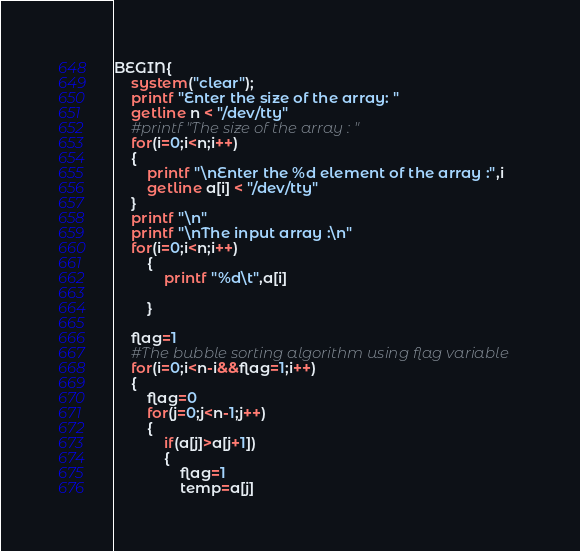<code> <loc_0><loc_0><loc_500><loc_500><_Awk_>BEGIN{
	system("clear");
	printf "Enter the size of the array: "
	getline n < "/dev/tty"
	#printf "The size of the array : "	
	for(i=0;i<n;i++)
	{
		printf "\nEnter the %d element of the array :",i
		getline a[i] < "/dev/tty"
	}
	printf "\n"
	printf "\nThe input array :\n"
	for(i=0;i<n;i++)
        {
        	printf "%d\t",a[i]
                
        }

	flag=1
	#The bubble sorting algorithm using flag variable
 	for(i=0;i<n-i&&flag=1;i++)
	{
		flag=0
		for(j=0;j<n-1;j++)
		{
			if(a[j]>a[j+1])
			{
				flag=1
				temp=a[j]</code> 